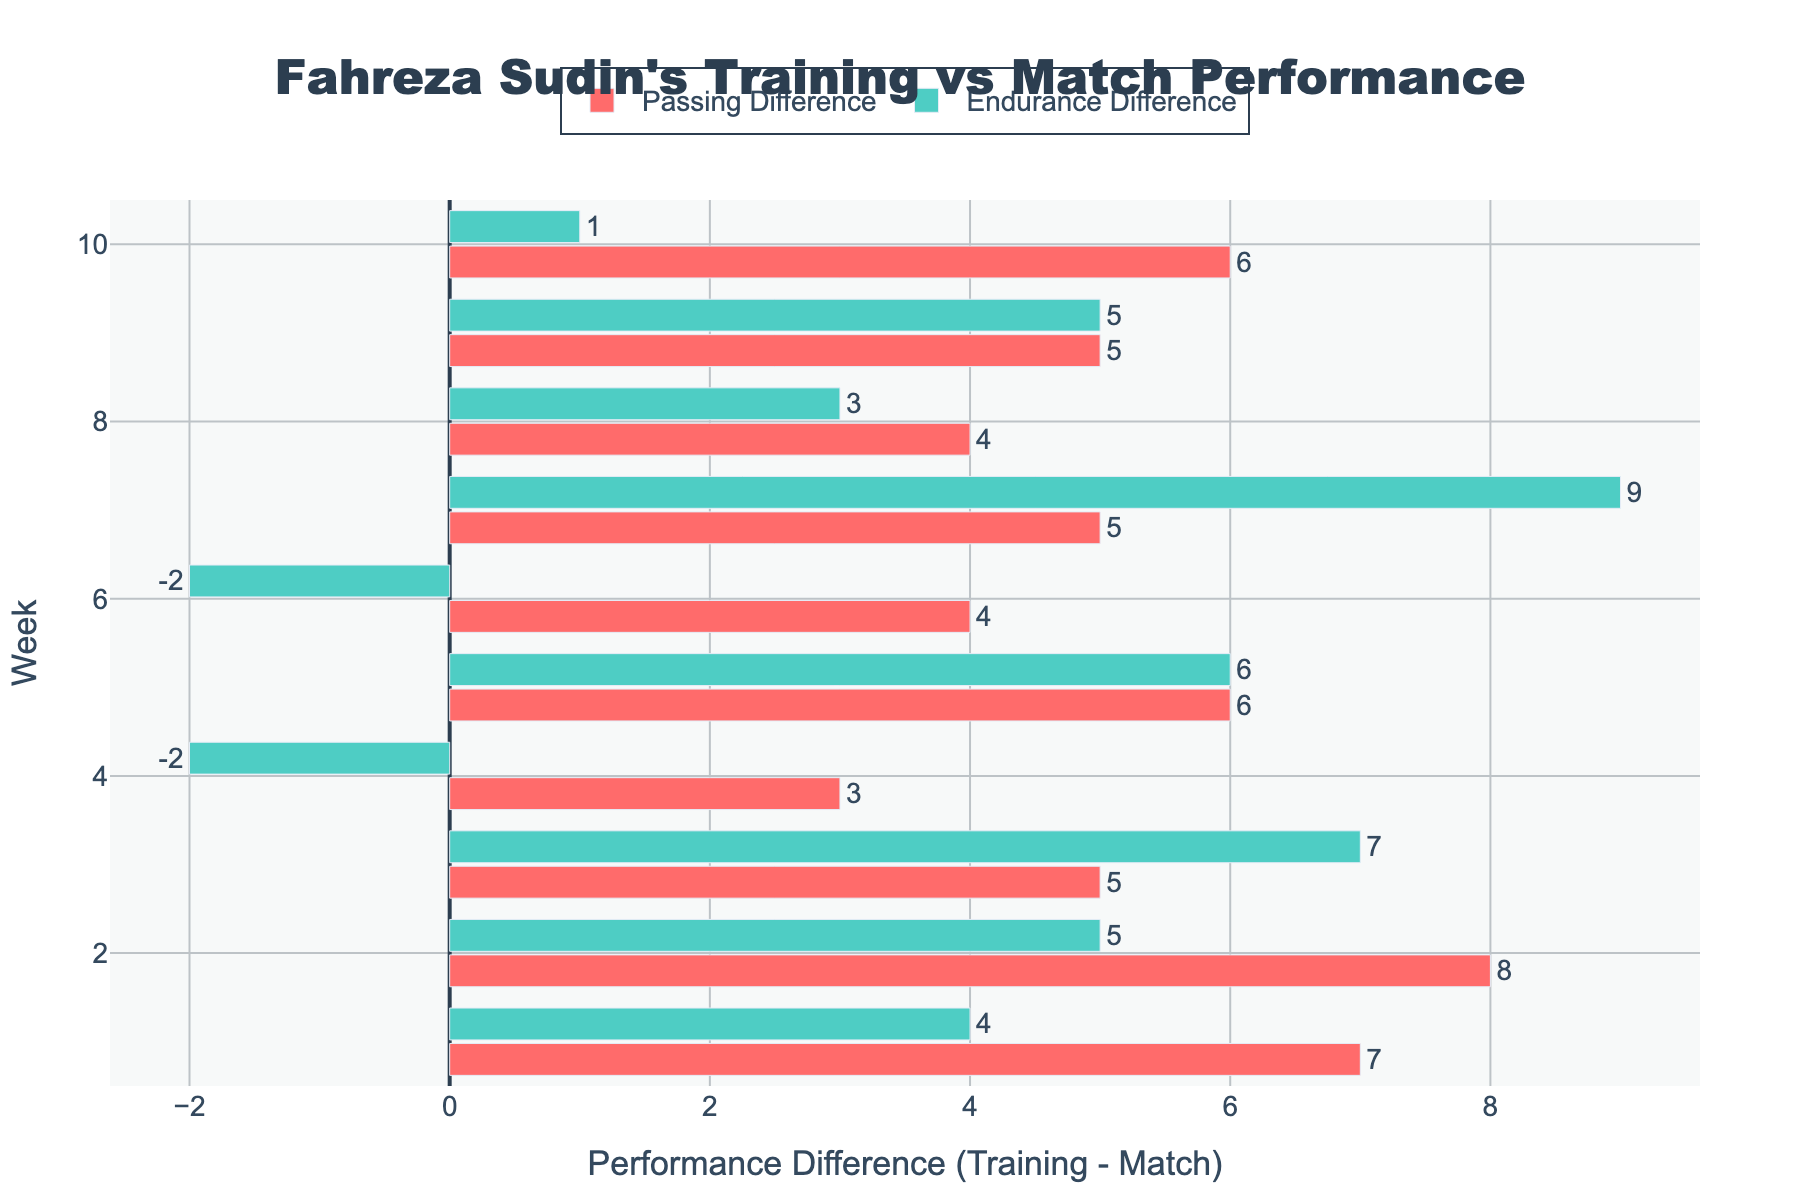What week shows the highest passing difference? To determine this, look for the longest red bar in the plot. The highest passing difference is 25.
Answer: Week 7 Which week has a higher endurance difference: week 2 or week 3? Compare the green bars for weeks 2 and 3. For week 2, the endurance difference is 5. For week 3, it's 7.
Answer: Week 3 What is the overall trend in passing differences from week 1 to week 10? Observe the red bars from week 1 to week 10 and note whether they are generally increasing, decreasing, or remaining stable. The differences fluctuate but neither consistently increase nor decrease.
Answer: Fluctuating What's the average passing difference over the first 5 weeks? Sum the passing differences for weeks 1 through 5 and divide by 5. Differences: 7, 8, 5, 3, 6. (7 + 8 + 5 + 3 + 6) / 5 = 5.8.
Answer: 5.8 Which week has the lowest endurance difference? Identify the green bar that is shortest. Week 5’s bar is smallest with a difference of -6.
Answer: Week 5 Between week 4 and week 6, which week shows a smaller difference from training to match in endurance? Compare the lengths of the green bars for weeks 4 and 6. Week 4 has a difference of -2, and week 6 has a difference of -2, indicating that both weeks have the same.
Answer: Both weeks In which week is the passing difference closest to zero? Find the red bar that is closest to zero. Week 4 has the smallest passing difference of 3.
Answer: Week 4 What is the combined difference in endurance for weeks 1, 2, and 3? Add the numbers for the green bars in weeks 1, 2, and 3. Endurance differences: -4, 5, 7. (-4 + 5 + 7) = 8.
Answer: 8 Which color represents the passing difference, and what does it signify? The chart uses red for passing differences. A red bar signifies the difference between training drills scores and match passing accuracy.
Answer: Red Comparing passing and endurance differences for week 7, which is larger? Examine the bar lengths for both metrics in week 7. Passing difference is 25, and endurance difference is 4. Passing difference is larger.
Answer: Passing difference 